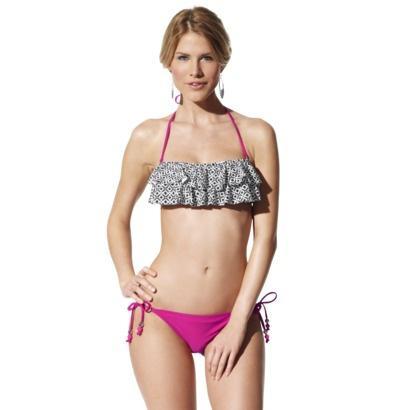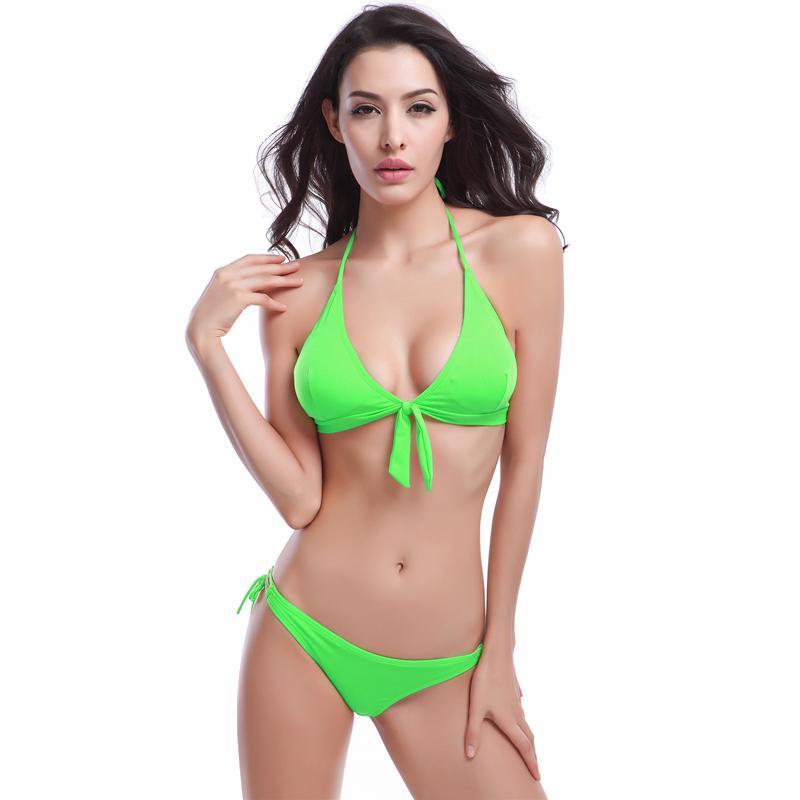The first image is the image on the left, the second image is the image on the right. Given the left and right images, does the statement "At least one of the bikini models pictured is a child." hold true? Answer yes or no. No. 